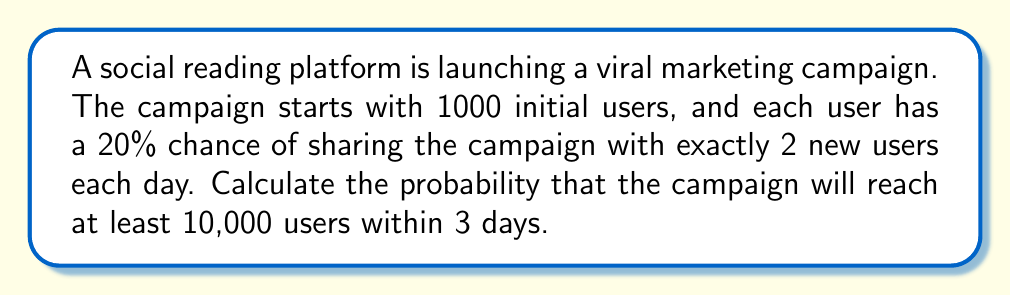Could you help me with this problem? Let's approach this step-by-step:

1) First, we need to calculate the expected number of users after 3 days:

   Day 0: 1000 users
   Day 1: $1000 + 1000 \cdot 0.2 \cdot 2 = 1400$ users
   Day 2: $1400 + 1400 \cdot 0.2 \cdot 2 = 1960$ users
   Day 3: $1960 + 1960 \cdot 0.2 \cdot 2 = 2744$ users

2) The number of new users added each day follows a binomial distribution. Let $X$ be the number of new users added on a given day. Then:

   $X \sim B(n, p)$, where $n$ is the number of current users, and $p = 0.4$ (0.2 chance of sharing with 2 users)

3) The total number of users after 3 days can be modeled as a sum of binomial distributions:

   $Y = 1000 + X_1 + X_2 + X_3$

   where $X_1 \sim B(1000, 0.4)$, $X_2 \sim B(1000+X_1, 0.4)$, and $X_3 \sim B(1000+X_1+X_2, 0.4)$

4) This sum doesn't follow a simple distribution, but we can approximate it using the Central Limit Theorem. The sum will be approximately normally distributed with:

   $\mu = 2744$ (calculated in step 1)
   $\sigma^2 = 1000 \cdot 0.4 \cdot 0.6 + 1400 \cdot 0.4 \cdot 0.6 + 1960 \cdot 0.4 \cdot 0.6 = 1044$
   $\sigma = \sqrt{1044} \approx 32.31$

5) We want $P(Y \geq 10000)$. Using the normal approximation:

   $z = \frac{10000 - 2744}{32.31} \approx 224.7$

6) The probability of a z-score this high is essentially 0.
Answer: $\approx 0$ 